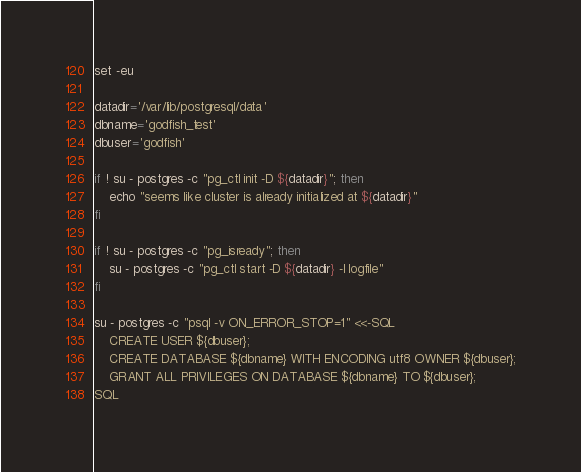<code> <loc_0><loc_0><loc_500><loc_500><_Bash_>
set -eu

datadir='/var/lib/postgresql/data'
dbname='godfish_test'
dbuser='godfish'

if ! su - postgres -c "pg_ctl init -D ${datadir}"; then
	echo "seems like cluster is already initialized at ${datadir}"
fi

if ! su - postgres -c "pg_isready"; then
	su - postgres -c "pg_ctl start -D ${datadir} -l logfile"
fi

su - postgres -c "psql -v ON_ERROR_STOP=1" <<-SQL
	CREATE USER ${dbuser};
	CREATE DATABASE ${dbname} WITH ENCODING utf8 OWNER ${dbuser};
	GRANT ALL PRIVILEGES ON DATABASE ${dbname} TO ${dbuser};
SQL
</code> 